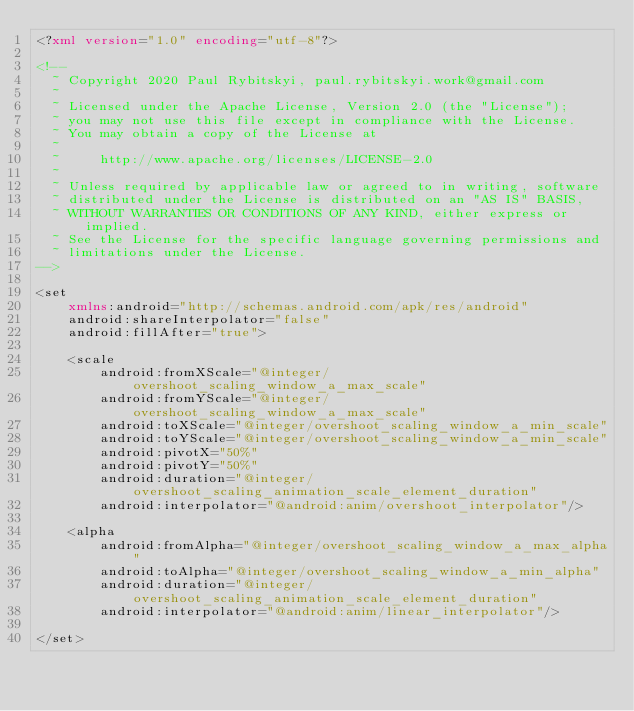Convert code to text. <code><loc_0><loc_0><loc_500><loc_500><_XML_><?xml version="1.0" encoding="utf-8"?>

<!--
  ~ Copyright 2020 Paul Rybitskyi, paul.rybitskyi.work@gmail.com
  ~
  ~ Licensed under the Apache License, Version 2.0 (the "License");
  ~ you may not use this file except in compliance with the License.
  ~ You may obtain a copy of the License at
  ~
  ~     http://www.apache.org/licenses/LICENSE-2.0
  ~
  ~ Unless required by applicable law or agreed to in writing, software
  ~ distributed under the License is distributed on an "AS IS" BASIS,
  ~ WITHOUT WARRANTIES OR CONDITIONS OF ANY KIND, either express or implied.
  ~ See the License for the specific language governing permissions and
  ~ limitations under the License.
-->

<set
    xmlns:android="http://schemas.android.com/apk/res/android"
    android:shareInterpolator="false"
    android:fillAfter="true">

    <scale
        android:fromXScale="@integer/overshoot_scaling_window_a_max_scale"
        android:fromYScale="@integer/overshoot_scaling_window_a_max_scale"
        android:toXScale="@integer/overshoot_scaling_window_a_min_scale"
        android:toYScale="@integer/overshoot_scaling_window_a_min_scale"
        android:pivotX="50%"
        android:pivotY="50%"
        android:duration="@integer/overshoot_scaling_animation_scale_element_duration"
        android:interpolator="@android:anim/overshoot_interpolator"/>

    <alpha
        android:fromAlpha="@integer/overshoot_scaling_window_a_max_alpha"
        android:toAlpha="@integer/overshoot_scaling_window_a_min_alpha"
        android:duration="@integer/overshoot_scaling_animation_scale_element_duration"
        android:interpolator="@android:anim/linear_interpolator"/>

</set></code> 